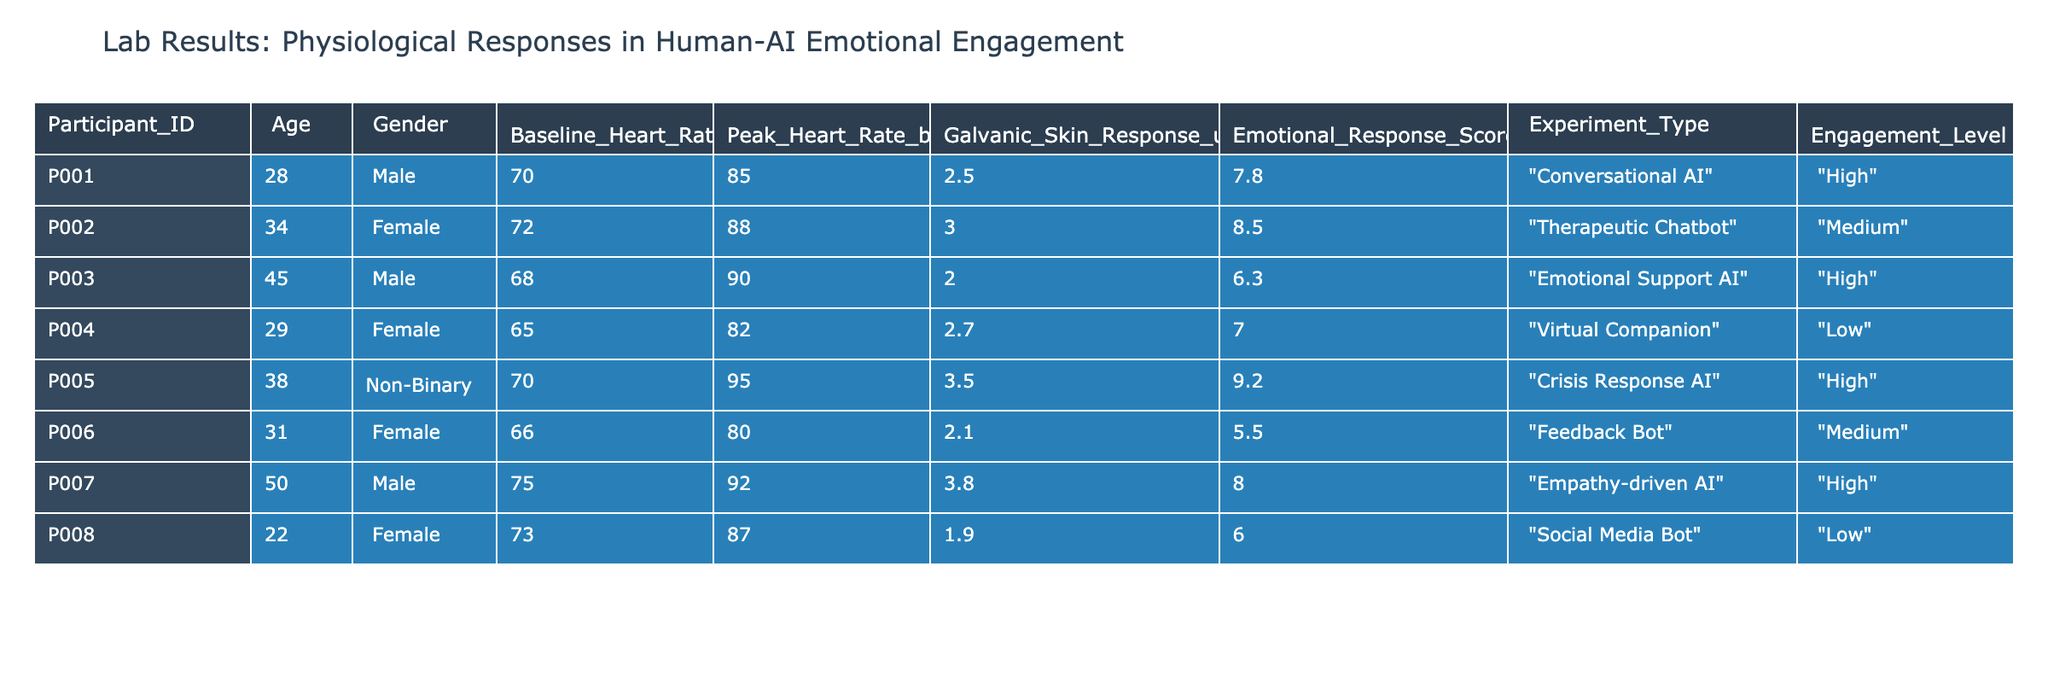What is the Peak Heart Rate (bpm) of Participant P005? According to the table, Participant P005 has a Peak Heart Rate of 95 bpm listed in the Peak Heart Rate (bpm) column.
Answer: 95 bpm Which participant experienced the highest Emotional Response Score? Looking through the Emotional Response Score column, Participant P005 has the highest score listed as 9.2.
Answer: Participant P005 What is the average Baseline Heart Rate (bpm) of all participants? To find the average Baseline Heart Rate, sum all the Baseline Heart Rate values: (70 + 72 + 68 + 65 + 70 + 66 + 75 + 73) = 519. There are 8 participants, so the average is 519/8 = 64.88.
Answer: 64.88 bpm Did any participant have a Low engagement level with a high Peak Heart Rate? Checking the table for Low engagement level with Peak Heart Rate, Participant P004 has a Peak Heart Rate of 82 bpm and an engagement level categorized as Low, which fulfills the criterion.
Answer: Yes What is the difference between the highest and lowest Galvanic Skin Response values? The highest Galvanic Skin Response is 3.8 (Participant P007) and the lowest is 1.9 (Participant P008). The difference is calculated as 3.8 - 1.9 = 1.9.
Answer: 1.9 uS Which gender had the highest average Emotional Response Score? First, calculate the average Emotional Response Score for each gender. For males: (7.8 + 6.3 + 8.0) / 3 = 7.0333; for females: (8.5 + 7.0 + 5.5) / 3 = 7.3333; and for non-binary: 9.2 (only one participant). The highest average is for non-binary with 9.2.
Answer: Non-binary How many participants had a "High" engagement level? Count the number of participants listed with "High" in the Engagement Level column: P001, P003, P005, and P007. There are 4 participants.
Answer: 4 participants Was there any female participant with a Peak Heart Rate above 85 bpm? Reviewing the data, Participant P002 has a Peak Heart Rate of 88 bpm but P004 has a Peak Heart Rate of 82 bpm. So only P002 qualifies.
Answer: Yes 